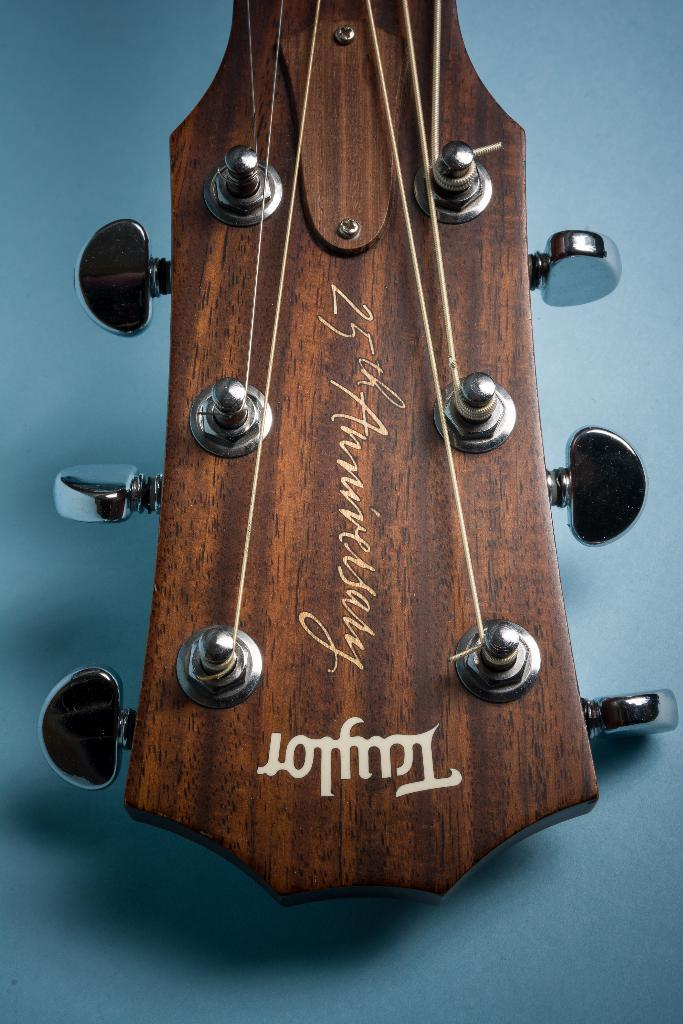What musical instrument is present in the image? There is a guitar in the image. What feature of the guitar can be seen in the image? The guitar has tuners. How does the cow stretch in the image? There is no cow present in the image, so it cannot be stretched or perform any actions. 